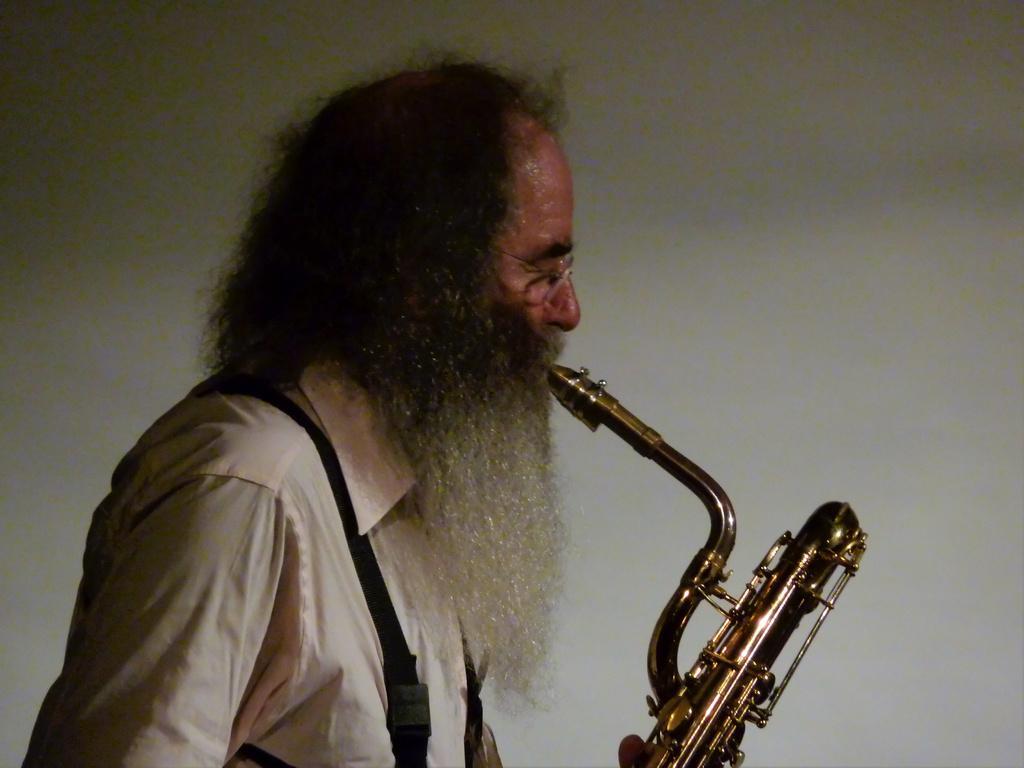Please provide a concise description of this image. In this picture we can see a person, here we can see a saxophone and we can see a wall in the background. 